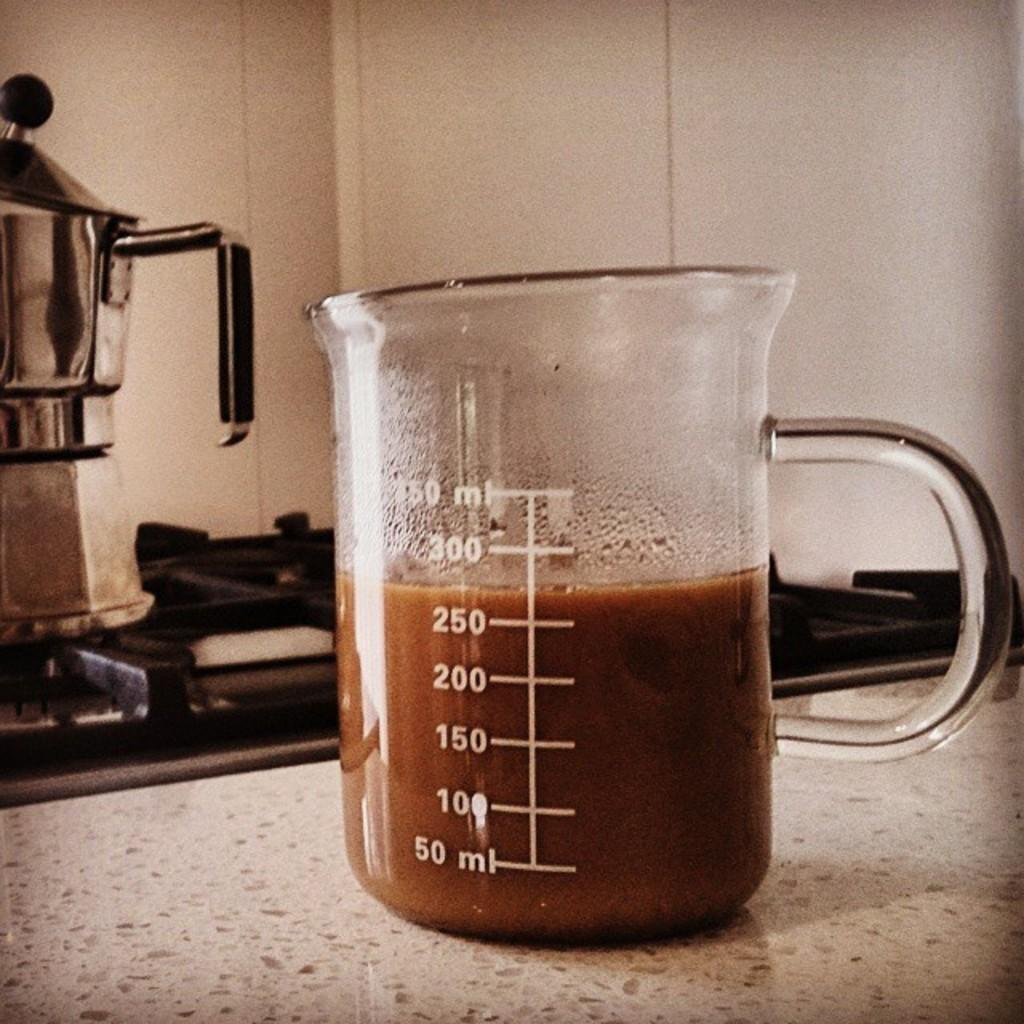<image>
Give a short and clear explanation of the subsequent image. A measuring cup with liquid measuring 275 milliliters 